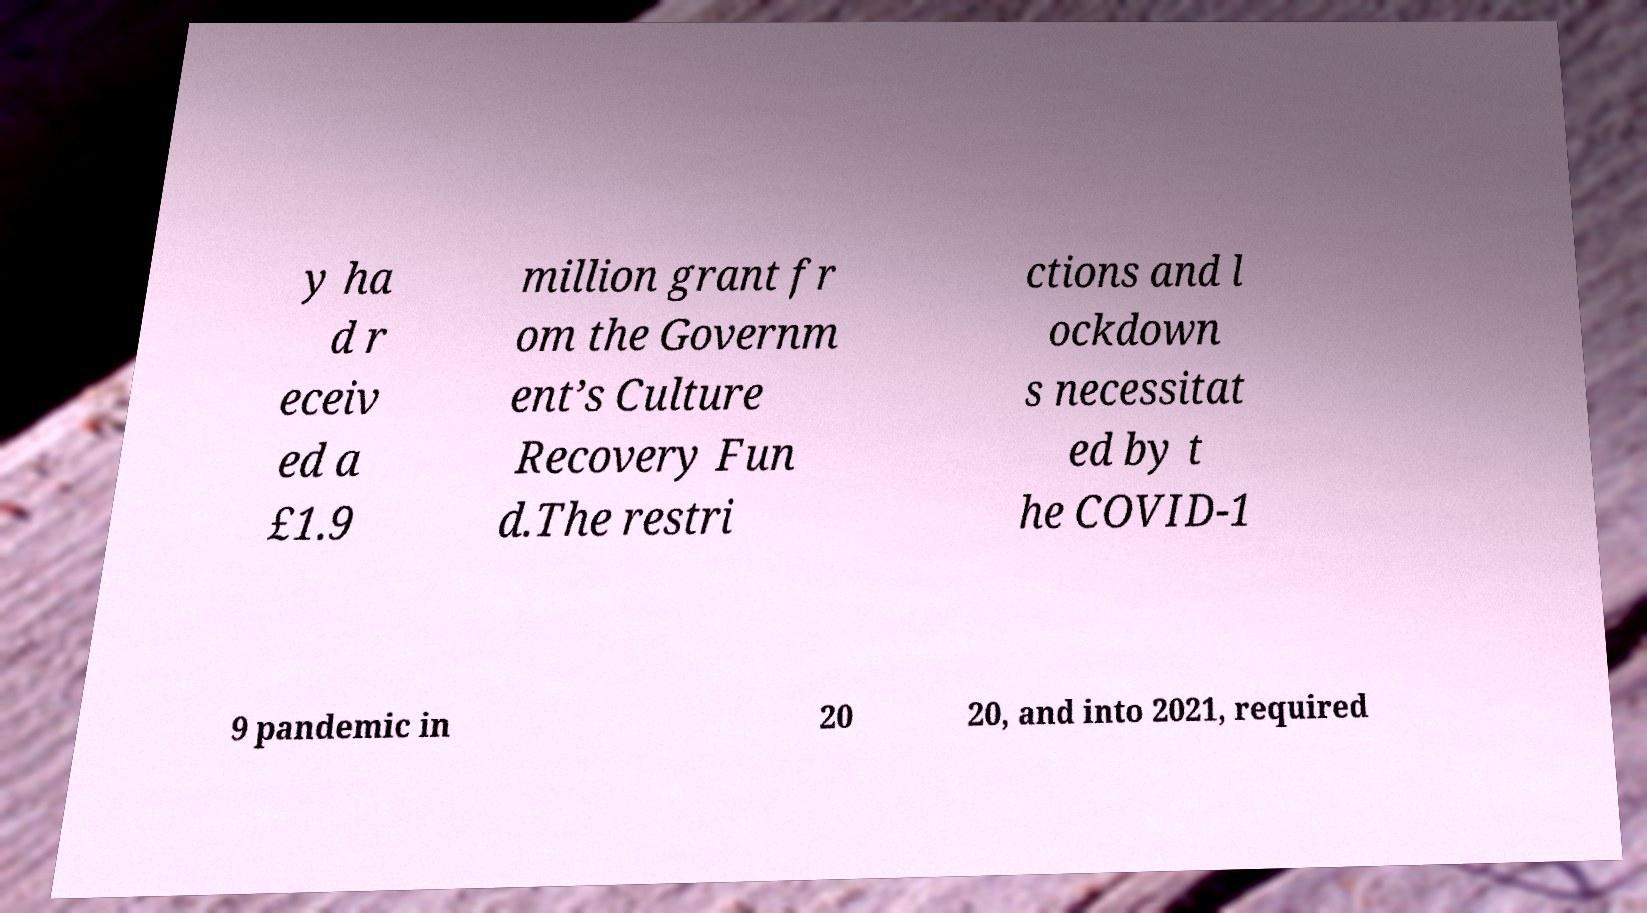Could you extract and type out the text from this image? y ha d r eceiv ed a £1.9 million grant fr om the Governm ent’s Culture Recovery Fun d.The restri ctions and l ockdown s necessitat ed by t he COVID-1 9 pandemic in 20 20, and into 2021, required 